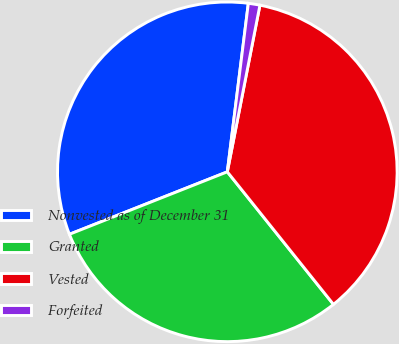Convert chart. <chart><loc_0><loc_0><loc_500><loc_500><pie_chart><fcel>Nonvested as of December 31<fcel>Granted<fcel>Vested<fcel>Forfeited<nl><fcel>32.97%<fcel>29.75%<fcel>36.18%<fcel>1.1%<nl></chart> 